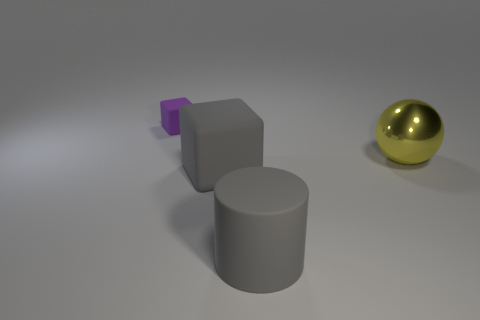Add 2 big blue metallic blocks. How many objects exist? 6 Subtract all gray blocks. How many blocks are left? 1 Subtract all spheres. How many objects are left? 3 Subtract 1 cubes. How many cubes are left? 1 Subtract all green cylinders. Subtract all green spheres. How many cylinders are left? 1 Subtract all matte cubes. Subtract all large yellow balls. How many objects are left? 1 Add 4 yellow objects. How many yellow objects are left? 5 Add 3 large yellow objects. How many large yellow objects exist? 4 Subtract 0 brown spheres. How many objects are left? 4 